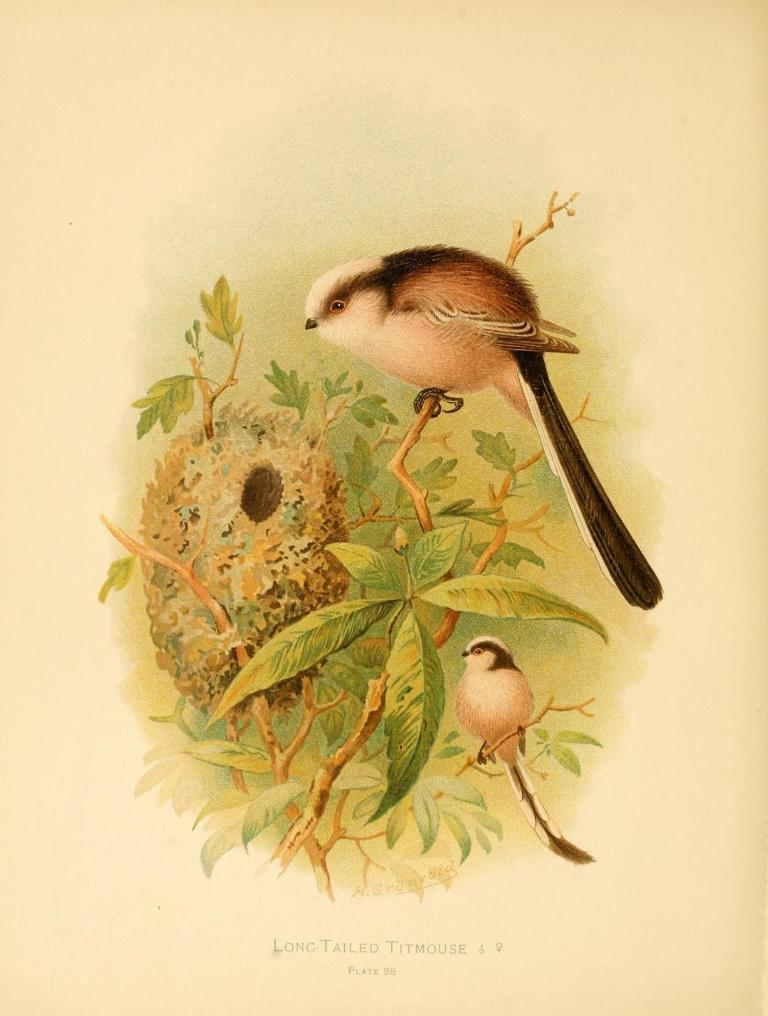What is the main object in the image? There is a tree in the image. What is located on the tree? There is a bird nest on the tree. How many birds can be seen in the image? There are two birds in the image. What colors are the birds? The birds are cream, brown, and black in color. What color is the background of the image? The background of the image is cream colored. Can you tell me how many jail cells are visible in the image? There are no jail cells present in the image; it features a tree with a bird nest and two birds. What type of rail can be seen in the image? There is no rail present in the image; it features a tree with a bird nest and two birds. 